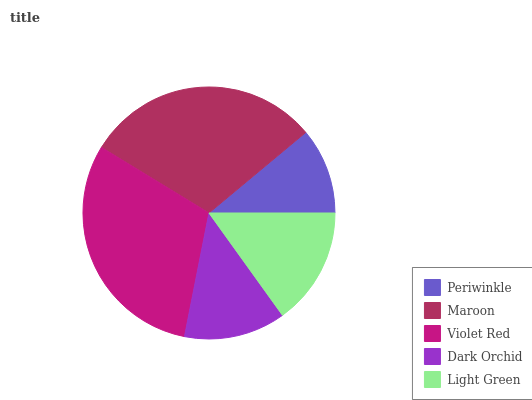Is Periwinkle the minimum?
Answer yes or no. Yes. Is Violet Red the maximum?
Answer yes or no. Yes. Is Maroon the minimum?
Answer yes or no. No. Is Maroon the maximum?
Answer yes or no. No. Is Maroon greater than Periwinkle?
Answer yes or no. Yes. Is Periwinkle less than Maroon?
Answer yes or no. Yes. Is Periwinkle greater than Maroon?
Answer yes or no. No. Is Maroon less than Periwinkle?
Answer yes or no. No. Is Light Green the high median?
Answer yes or no. Yes. Is Light Green the low median?
Answer yes or no. Yes. Is Dark Orchid the high median?
Answer yes or no. No. Is Periwinkle the low median?
Answer yes or no. No. 